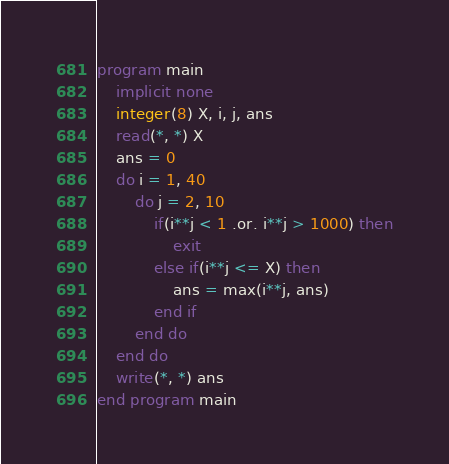<code> <loc_0><loc_0><loc_500><loc_500><_FORTRAN_>program main
    implicit none
    integer(8) X, i, j, ans
	read(*, *) X
	ans = 0
	do i = 1, 40
	    do j = 2, 10
			if(i**j < 1 .or. i**j > 1000) then
				exit
		    else if(i**j <= X) then
			    ans = max(i**j, ans)
			end if
		end do
	end do
	write(*, *) ans
end program main</code> 